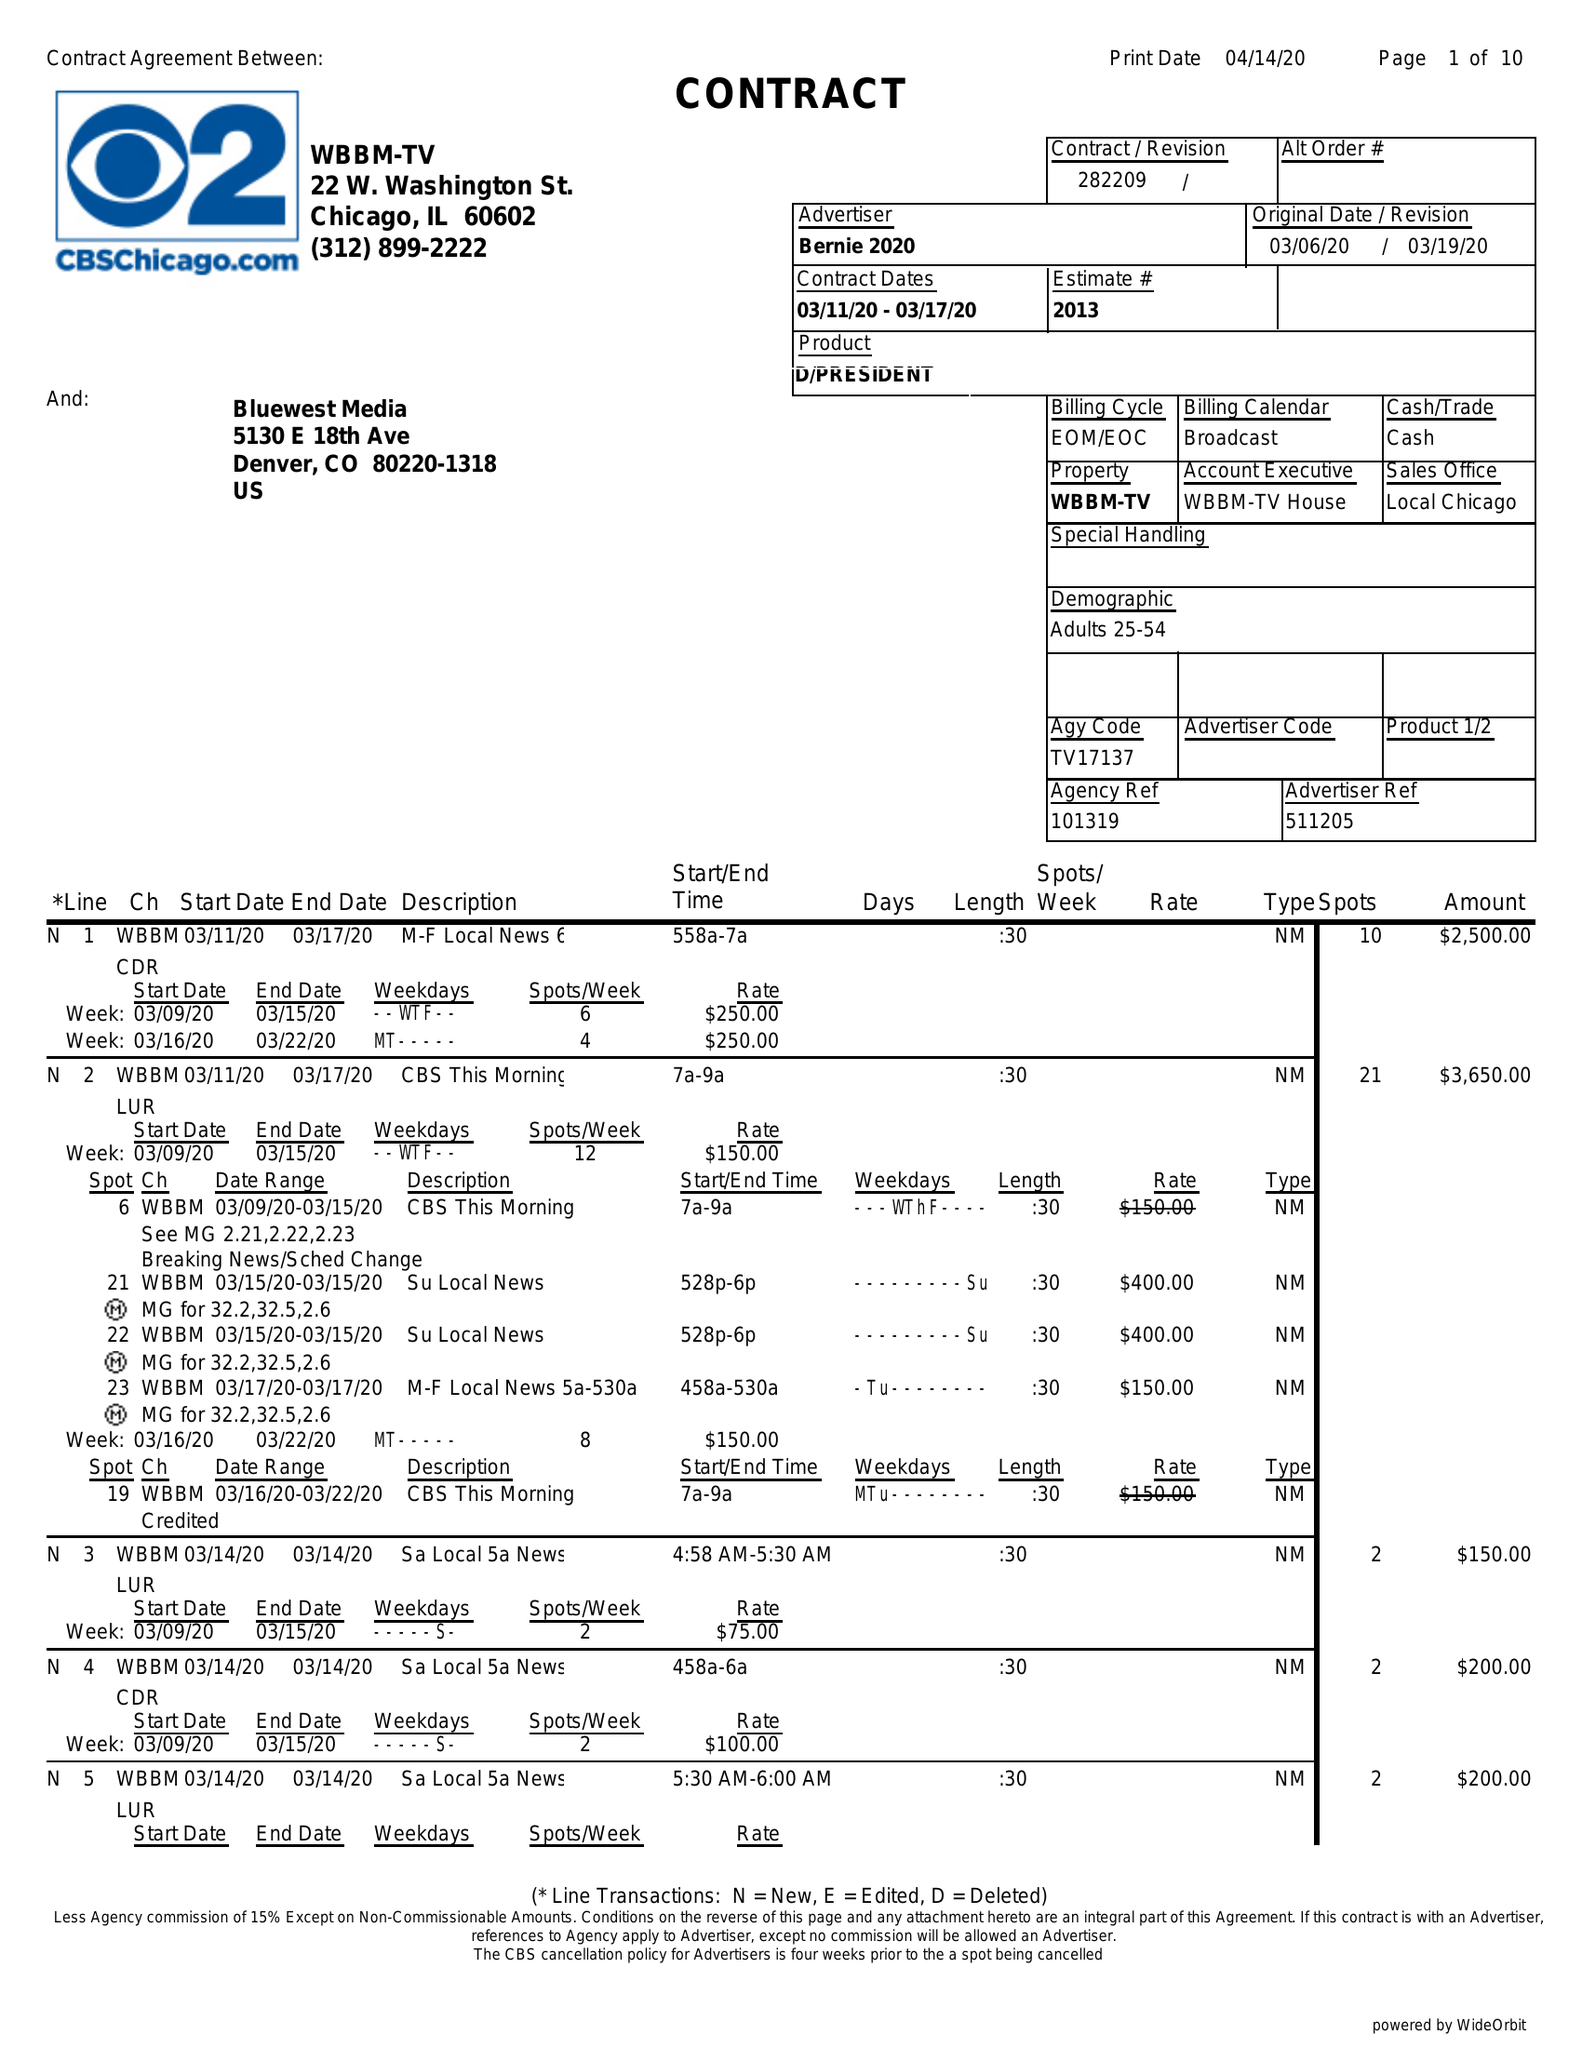What is the value for the gross_amount?
Answer the question using a single word or phrase. 142480.00 